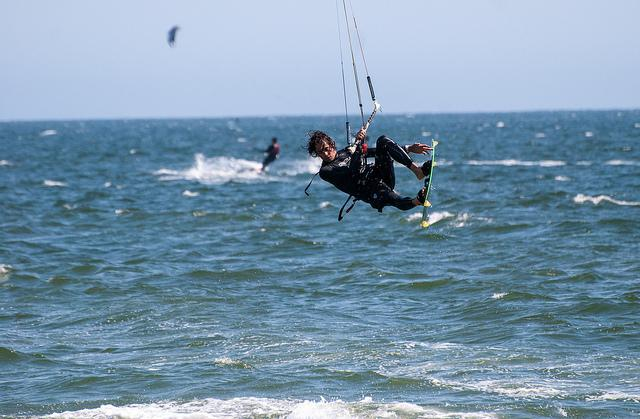What is above this person?

Choices:
A) drone
B) cloud
C) parasail
D) crane parasail 